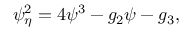<formula> <loc_0><loc_0><loc_500><loc_500>\psi _ { \eta } ^ { 2 } = 4 \psi ^ { 3 } - g _ { 2 } \psi - g _ { 3 } ,</formula> 